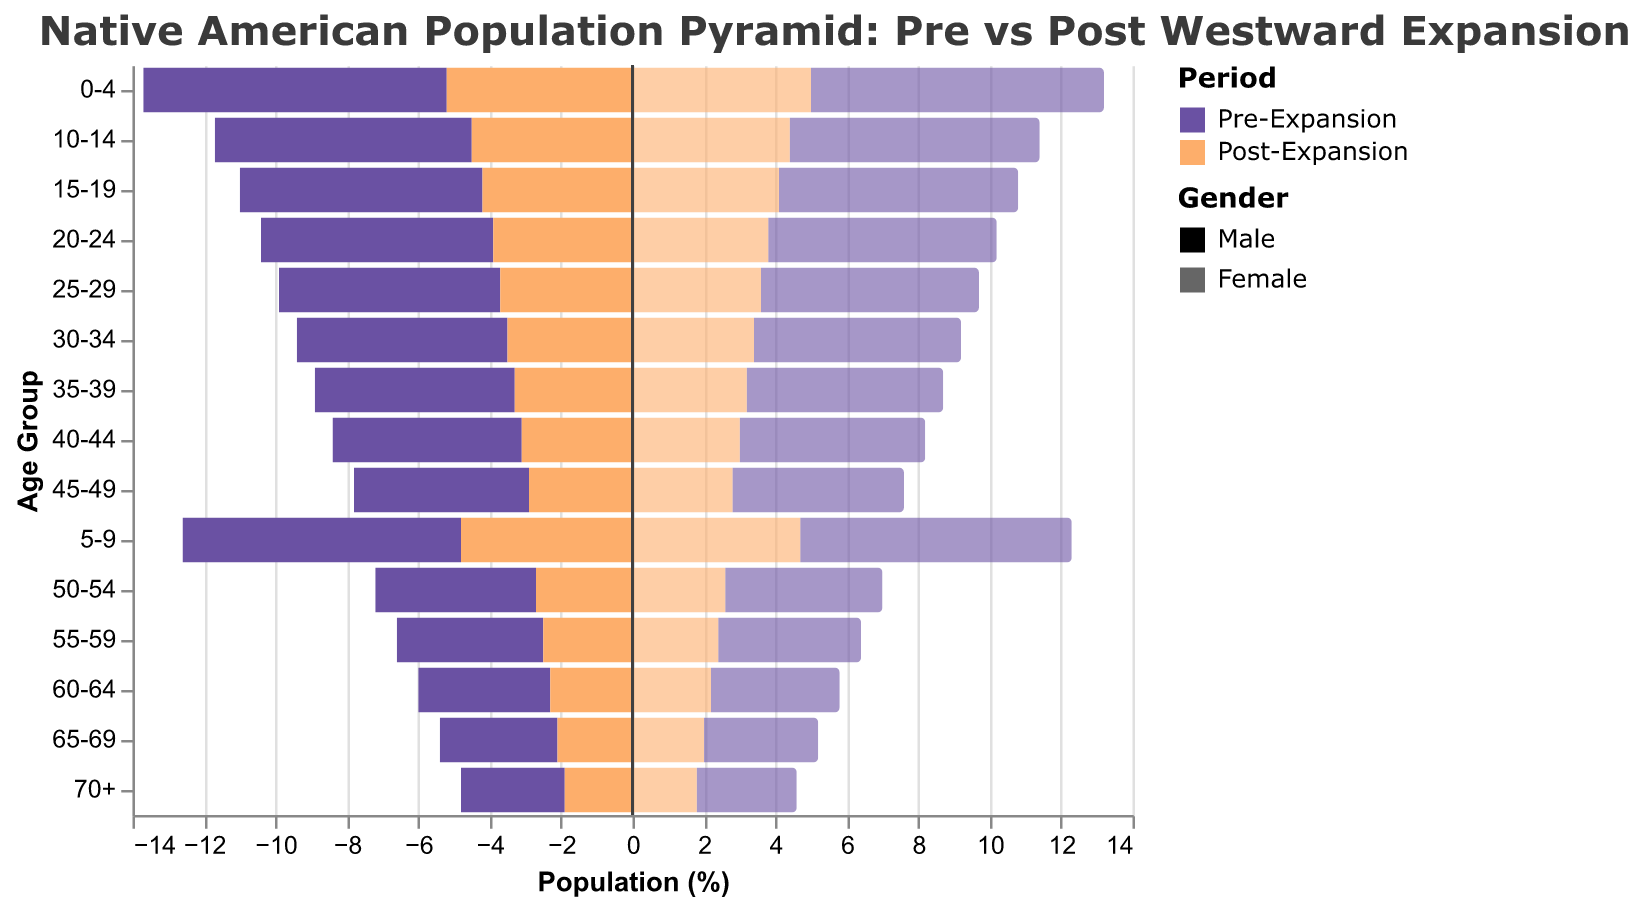What is the title of the figure? The title of the figure is usually located at the top and summarizes the content or essence of the figure. In this case, it reads "Native American Population Pyramid: Pre vs Post Westward Expansion".
Answer: Native American Population Pyramid: Pre vs Post Westward Expansion Which age group has the highest percentage of males in the pre-expansion period? To find this, we need to look at the bars for the pre-expansion period and identify which age group has the longest bar on the left side (negative values for males). The age group 0-4 has the highest percentage at 8.5%.
Answer: 0-4 What is the percentage difference in the 0-4 age group between the pre-expansion and post-expansion periods for females? We need to subtract the post-expansion percentage of females from the pre-expansion percentage of females in the 0-4 age group. This would be 8.2 - 5.0.
Answer: 3.2 Compare the trend in population distribution for males between pre-expansion and post-expansion periods. The bars for pre-expansion males generally show a greater percentage across all age groups compared to post-expansion males. This indicates a decrease in the male population across all age groups after the expansion.
Answer: Decrease across all age groups In which age group is the effect of westward expansion most pronounced for females? To determine this, we need to look for the age group with the largest difference between pre-expansion and post-expansion percentages for females. The 0-4 age group shows the largest difference (3.2%) for females (8.2% pre-expansion and 5.0% post-expansion).
Answer: 0-4 What can you infer about the old-age population (70+) based on the figure? By examining the bars for the 70+ age group, we observe that both pre-expansion and post-expansion periods have the lowest percentages compared to other age groups. The post-expansion shows a further decrease indicating perhaps higher mortality or displacement.
Answer: Consistently low How does the percentage of the 25-29 age group for females compare between the two periods? Looking at the figure, we can compare the length of the bars for females in the 25-29 age group across the two periods. The pre-expansion percentage is 6.1%, while the post-expansion percentage is 3.6%.
Answer: Higher in pre-expansion What is the overall trend in the population pyramid from pre-expansion to post-expansion? Observing the bars across all age groups, there's a clear trend where the population percentages for both genders are consistently higher in the pre-expansion period compared to post-expansion. This indicates a general decrease in population after westward expansion.
Answer: General decrease 